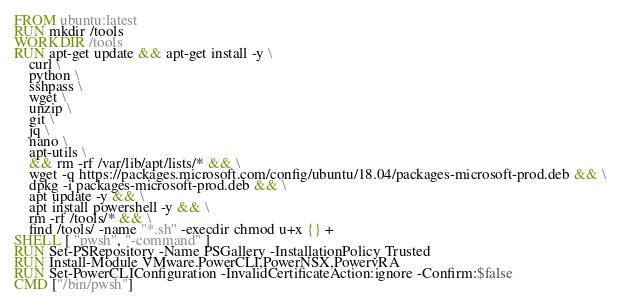<code> <loc_0><loc_0><loc_500><loc_500><_Dockerfile_>FROM ubuntu:latest
RUN mkdir /tools
WORKDIR /tools
RUN apt-get update && apt-get install -y \
    curl \
    python \
    sshpass \
    wget \
    unzip \
    git \
    jq \
    nano \
    apt-utils \
    && rm -rf /var/lib/apt/lists/* && \
    wget -q https://packages.microsoft.com/config/ubuntu/18.04/packages-microsoft-prod.deb && \
    dpkg -i packages-microsoft-prod.deb && \
    apt update -y && \
    apt install powershell -y && \
    rm -rf /tools/* && \
    find /tools/ -name "*.sh" -execdir chmod u+x {} +
SHELL [ "pwsh", "-command" ]
RUN Set-PSRepository -Name PSGallery -InstallationPolicy Trusted
RUN Install-Module VMware.PowerCLI,PowerNSX,PowervRA
RUN Set-PowerCLIConfiguration -InvalidCertificateAction:ignore -Confirm:$false
CMD ["/bin/pwsh"]
</code> 